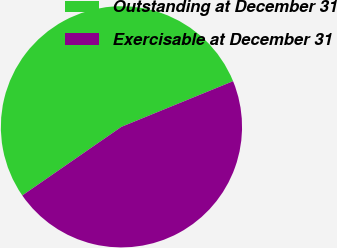Convert chart to OTSL. <chart><loc_0><loc_0><loc_500><loc_500><pie_chart><fcel>Outstanding at December 31<fcel>Exercisable at December 31<nl><fcel>53.46%<fcel>46.54%<nl></chart> 